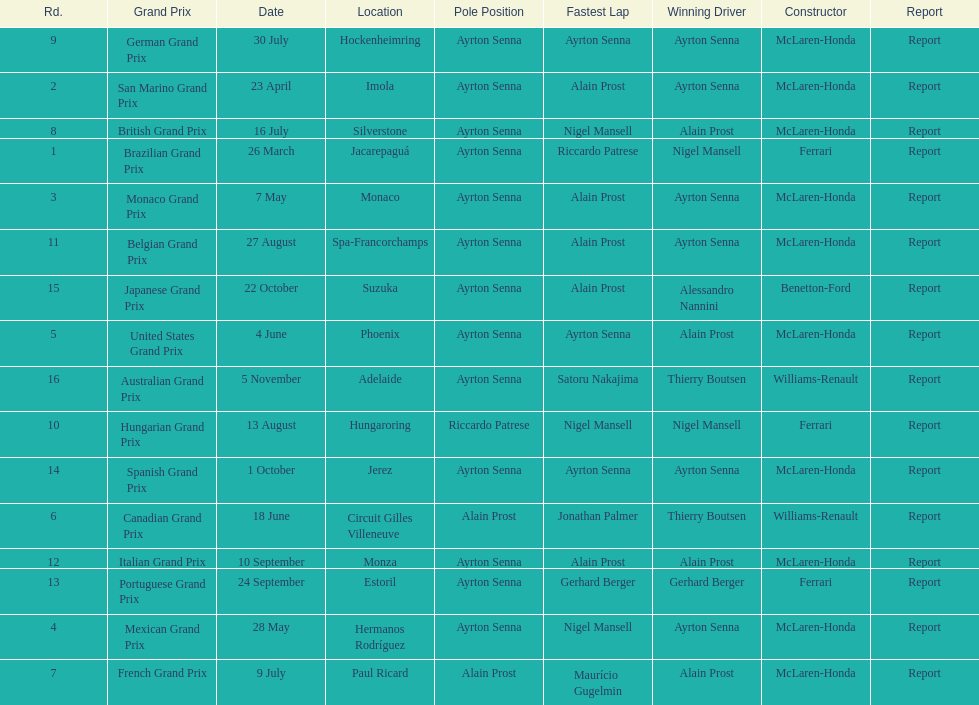How many did alain prost have the fastest lap? 5. 